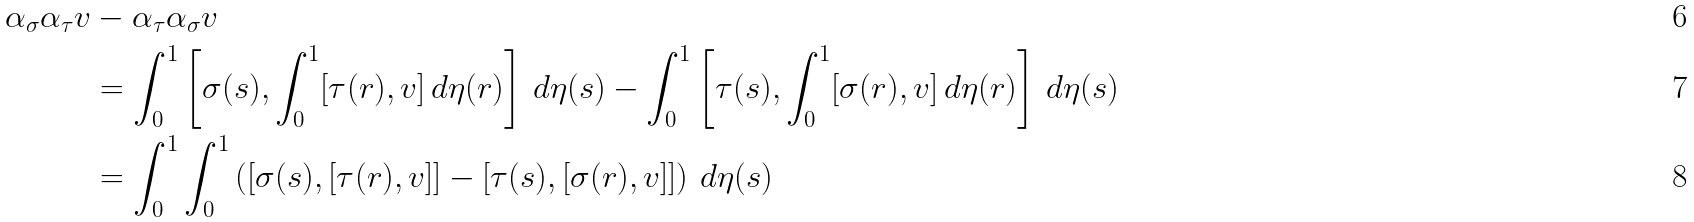Convert formula to latex. <formula><loc_0><loc_0><loc_500><loc_500>\alpha _ { \sigma } \alpha _ { \tau } v & - \alpha _ { \tau } \alpha _ { \sigma } v \\ & = \int _ { 0 } ^ { 1 } \left [ \sigma ( s ) , \int _ { 0 } ^ { 1 } [ \tau ( r ) , v ] \, d \eta ( r ) \right ] \, d \eta ( s ) - \int _ { 0 } ^ { 1 } \left [ \tau ( s ) , \int _ { 0 } ^ { 1 } [ \sigma ( r ) , v ] \, d \eta ( r ) \right ] \, d \eta ( s ) \\ & = \int _ { 0 } ^ { 1 } \int _ { 0 } ^ { 1 } \left ( [ \sigma ( s ) , [ \tau ( r ) , v ] ] - [ \tau ( s ) , [ \sigma ( r ) , v ] ] \right ) \, d \eta ( s )</formula> 